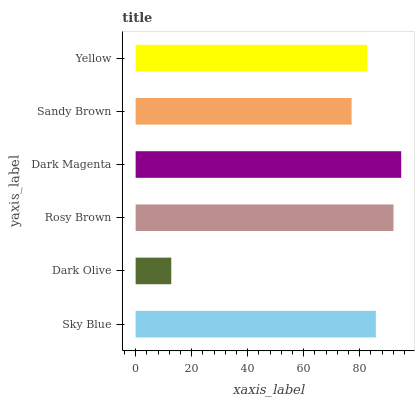Is Dark Olive the minimum?
Answer yes or no. Yes. Is Dark Magenta the maximum?
Answer yes or no. Yes. Is Rosy Brown the minimum?
Answer yes or no. No. Is Rosy Brown the maximum?
Answer yes or no. No. Is Rosy Brown greater than Dark Olive?
Answer yes or no. Yes. Is Dark Olive less than Rosy Brown?
Answer yes or no. Yes. Is Dark Olive greater than Rosy Brown?
Answer yes or no. No. Is Rosy Brown less than Dark Olive?
Answer yes or no. No. Is Sky Blue the high median?
Answer yes or no. Yes. Is Yellow the low median?
Answer yes or no. Yes. Is Yellow the high median?
Answer yes or no. No. Is Sky Blue the low median?
Answer yes or no. No. 